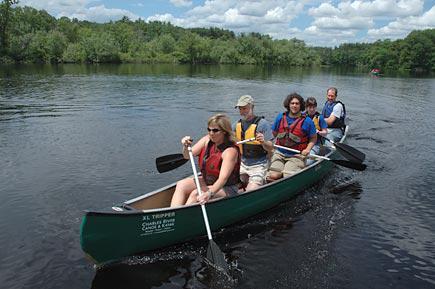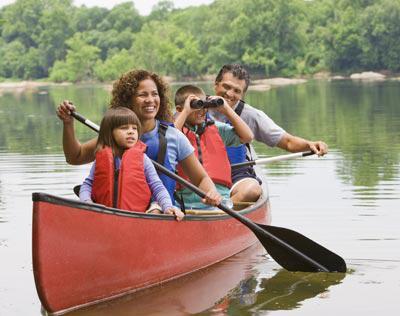The first image is the image on the left, the second image is the image on the right. For the images shown, is this caption "there are exactly two people in the image on the right" true? Answer yes or no. No. The first image is the image on the left, the second image is the image on the right. For the images shown, is this caption "There's at least one yellow paddle shown." true? Answer yes or no. No. 